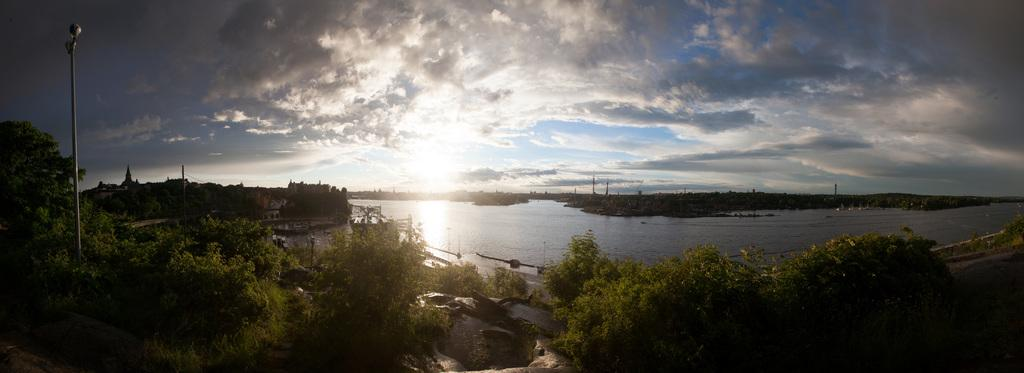What type of vegetation can be seen in the image? There are trees in the image. What structures are present in the image? There are poles in the image. What is visible in the sky in the image? There are clouds in the sky in the image. What natural element is visible at the bottom of the image? There is water visible at the bottom of the image. What direction is the creature in the image facing? There is no creature present in the image. How does the image relate to space exploration? The image does not depict any space-related elements or activities. 